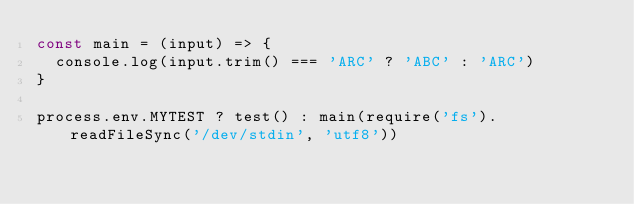Convert code to text. <code><loc_0><loc_0><loc_500><loc_500><_JavaScript_>const main = (input) => {
  console.log(input.trim() === 'ARC' ? 'ABC' : 'ARC')
}

process.env.MYTEST ? test() : main(require('fs').readFileSync('/dev/stdin', 'utf8'))</code> 